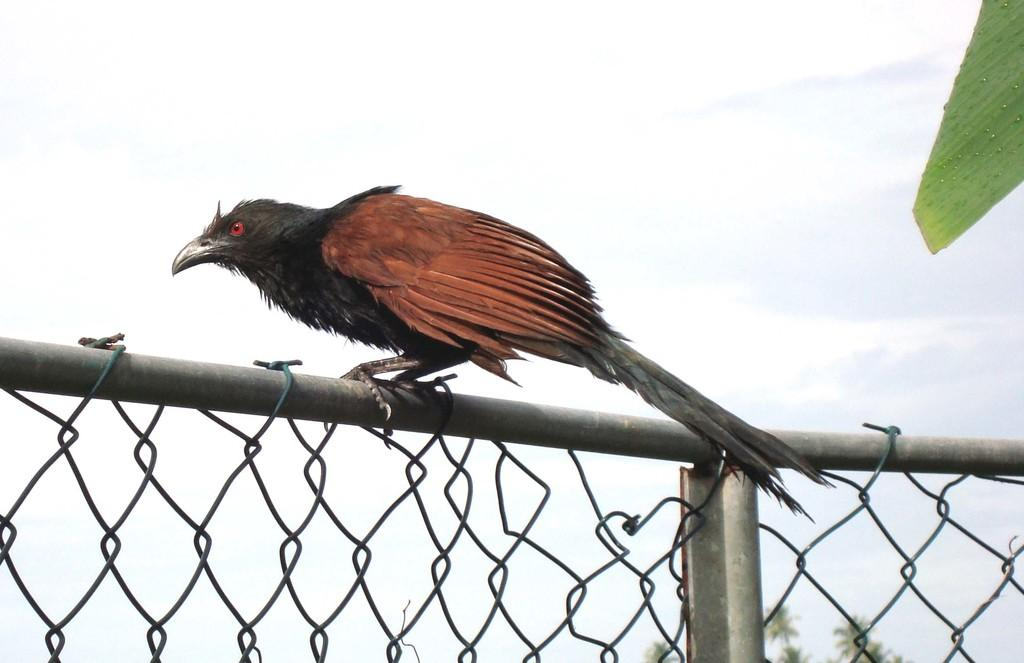What is located at the bottom of the image? There is a fencing at the bottom of the image. What can be seen on the fencing? A bird is present on the fencing. What is visible in the sky at the top of the image? There are clouds visible in the sky at the top of the image. What type of vegetation is behind the fencing? There is a tree behind the fencing. How many statements can be seen in the image? There are no statements present in the image. Can you describe the girls in the image? There are no girls present in the image. Is there a duck visible in the image? There is no duck present in the image. 